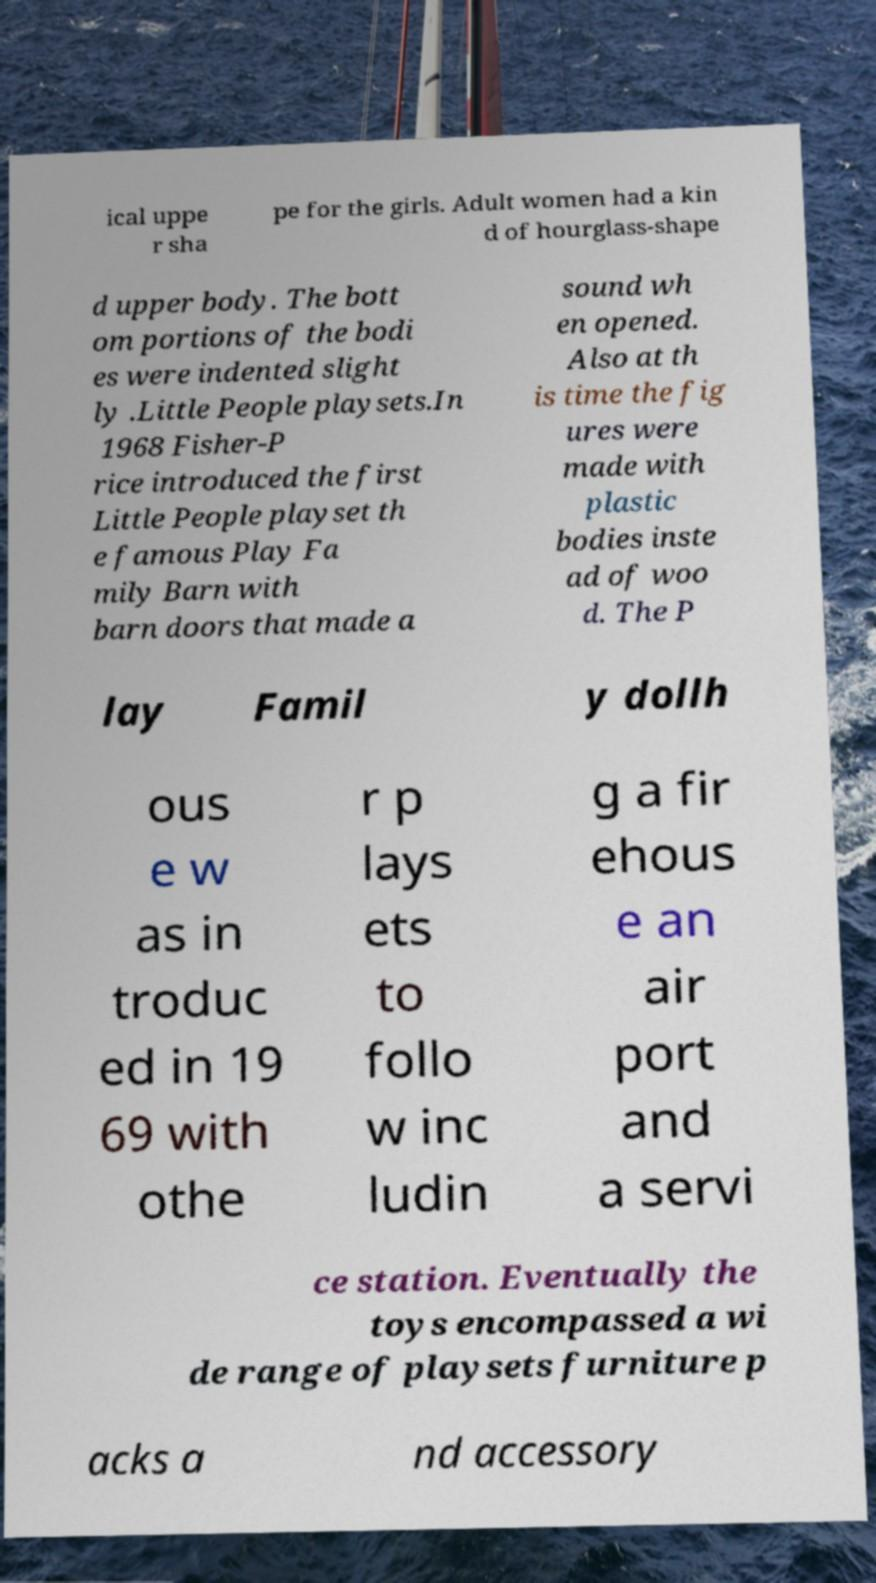There's text embedded in this image that I need extracted. Can you transcribe it verbatim? ical uppe r sha pe for the girls. Adult women had a kin d of hourglass-shape d upper body. The bott om portions of the bodi es were indented slight ly .Little People playsets.In 1968 Fisher-P rice introduced the first Little People playset th e famous Play Fa mily Barn with barn doors that made a sound wh en opened. Also at th is time the fig ures were made with plastic bodies inste ad of woo d. The P lay Famil y dollh ous e w as in troduc ed in 19 69 with othe r p lays ets to follo w inc ludin g a fir ehous e an air port and a servi ce station. Eventually the toys encompassed a wi de range of playsets furniture p acks a nd accessory 